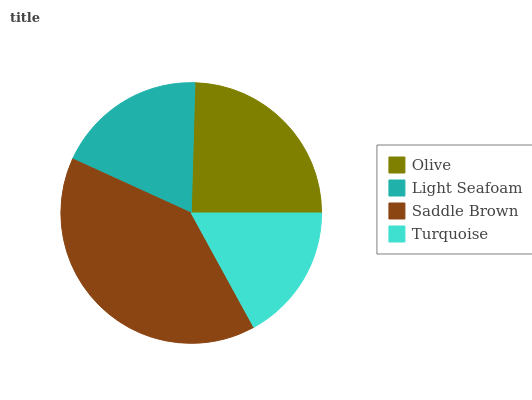Is Turquoise the minimum?
Answer yes or no. Yes. Is Saddle Brown the maximum?
Answer yes or no. Yes. Is Light Seafoam the minimum?
Answer yes or no. No. Is Light Seafoam the maximum?
Answer yes or no. No. Is Olive greater than Light Seafoam?
Answer yes or no. Yes. Is Light Seafoam less than Olive?
Answer yes or no. Yes. Is Light Seafoam greater than Olive?
Answer yes or no. No. Is Olive less than Light Seafoam?
Answer yes or no. No. Is Olive the high median?
Answer yes or no. Yes. Is Light Seafoam the low median?
Answer yes or no. Yes. Is Saddle Brown the high median?
Answer yes or no. No. Is Olive the low median?
Answer yes or no. No. 